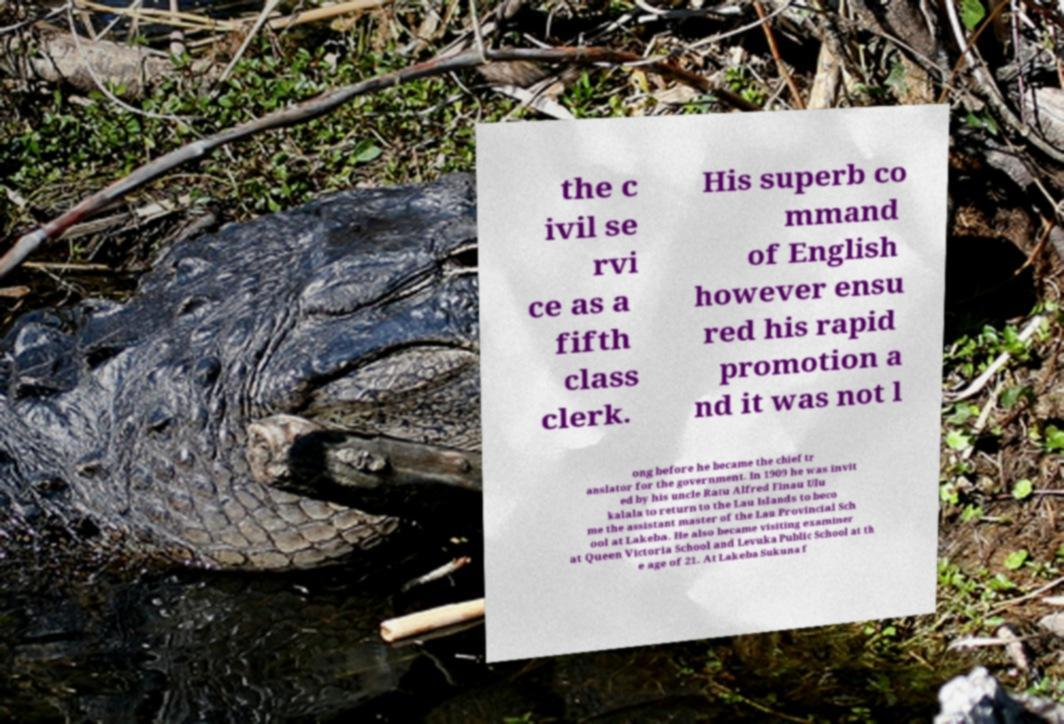Could you assist in decoding the text presented in this image and type it out clearly? the c ivil se rvi ce as a fifth class clerk. His superb co mmand of English however ensu red his rapid promotion a nd it was not l ong before he became the chief tr anslator for the government. In 1909 he was invit ed by his uncle Ratu Alfred Finau Ulu kalala to return to the Lau Islands to beco me the assistant master of the Lau Provincial Sch ool at Lakeba. He also became visiting examiner at Queen Victoria School and Levuka Public School at th e age of 21. At Lakeba Sukuna f 